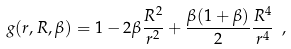Convert formula to latex. <formula><loc_0><loc_0><loc_500><loc_500>g ( r , R , \beta ) = 1 - 2 \beta \frac { R ^ { 2 } } { r ^ { 2 } } + \frac { \beta ( 1 + \beta ) } { 2 } \frac { R ^ { 4 } } { r ^ { 4 } } \ ,</formula> 